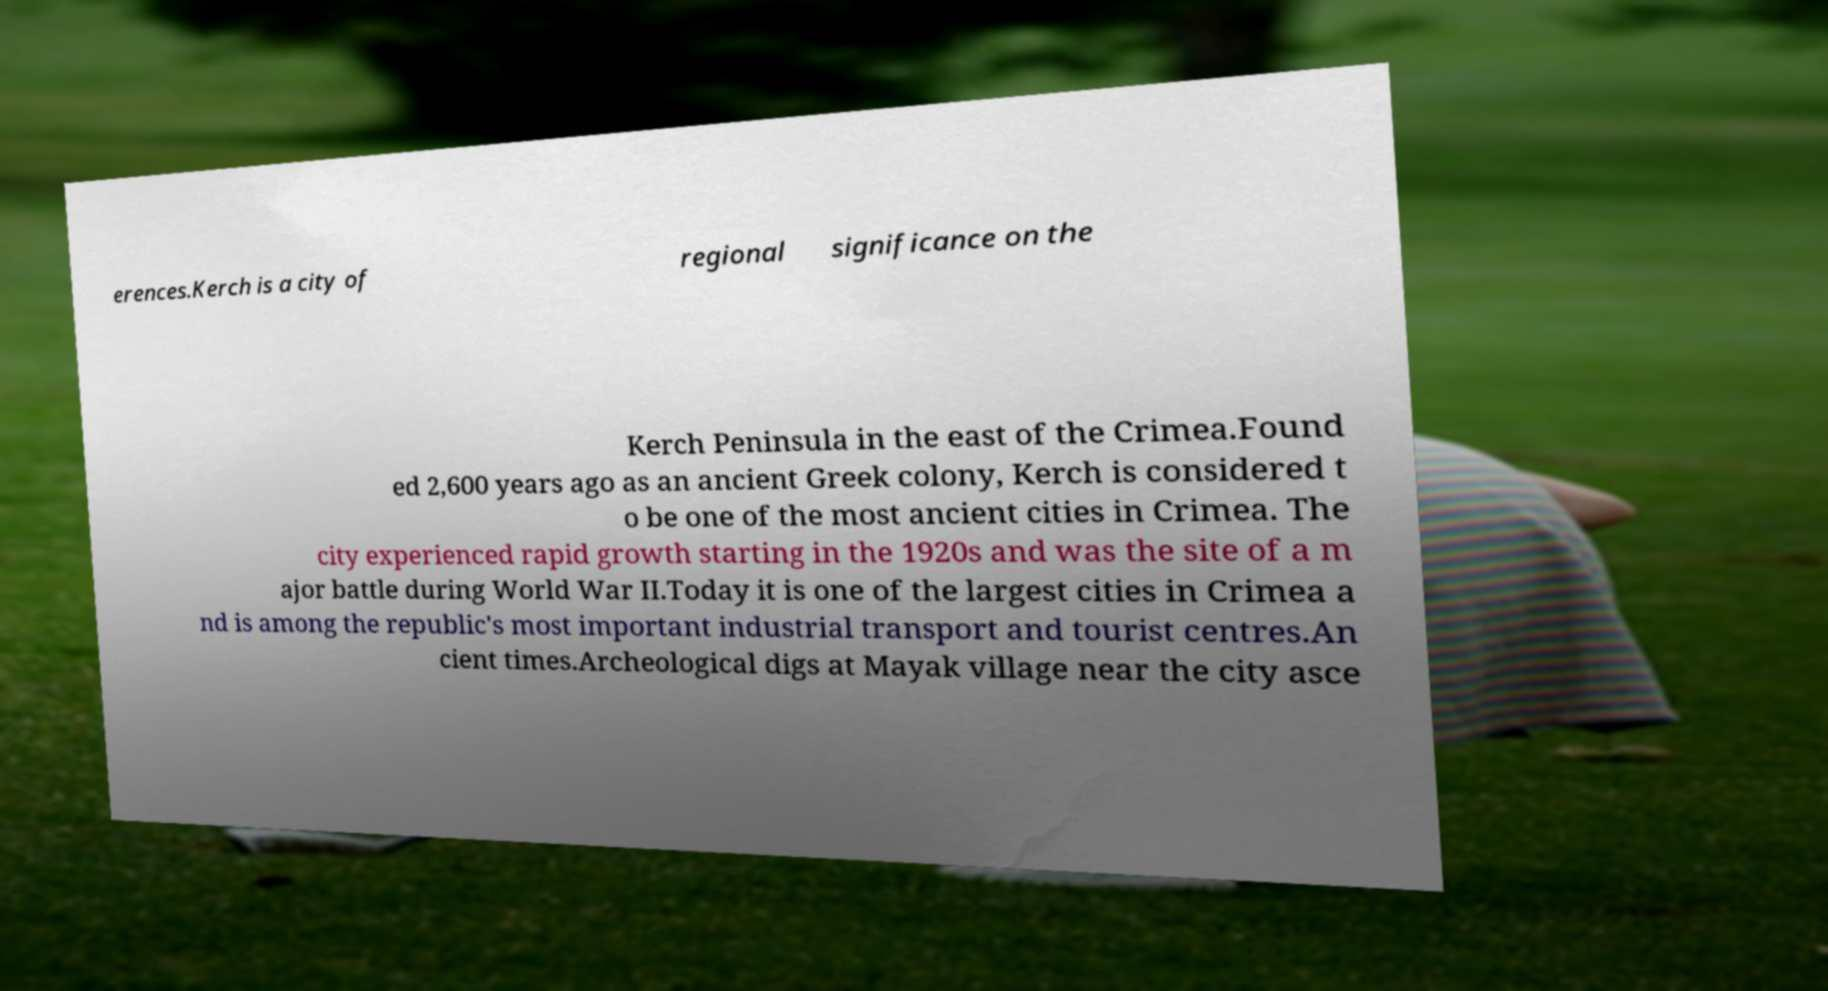I need the written content from this picture converted into text. Can you do that? erences.Kerch is a city of regional significance on the Kerch Peninsula in the east of the Crimea.Found ed 2,600 years ago as an ancient Greek colony, Kerch is considered t o be one of the most ancient cities in Crimea. The city experienced rapid growth starting in the 1920s and was the site of a m ajor battle during World War II.Today it is one of the largest cities in Crimea a nd is among the republic's most important industrial transport and tourist centres.An cient times.Archeological digs at Mayak village near the city asce 